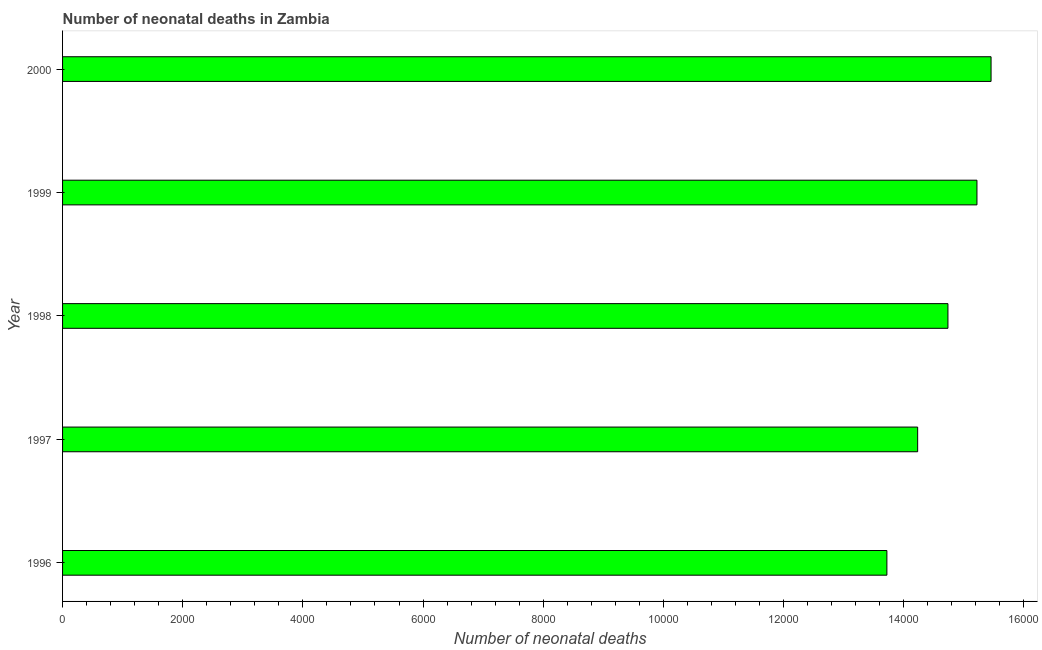Does the graph contain grids?
Your response must be concise. No. What is the title of the graph?
Keep it short and to the point. Number of neonatal deaths in Zambia. What is the label or title of the X-axis?
Your response must be concise. Number of neonatal deaths. What is the number of neonatal deaths in 1999?
Keep it short and to the point. 1.52e+04. Across all years, what is the maximum number of neonatal deaths?
Offer a very short reply. 1.55e+04. Across all years, what is the minimum number of neonatal deaths?
Make the answer very short. 1.37e+04. In which year was the number of neonatal deaths maximum?
Your answer should be very brief. 2000. What is the sum of the number of neonatal deaths?
Your answer should be very brief. 7.34e+04. What is the difference between the number of neonatal deaths in 1997 and 2000?
Ensure brevity in your answer.  -1222. What is the average number of neonatal deaths per year?
Your response must be concise. 1.47e+04. What is the median number of neonatal deaths?
Provide a succinct answer. 1.47e+04. What is the ratio of the number of neonatal deaths in 1996 to that in 1997?
Your response must be concise. 0.96. Is the number of neonatal deaths in 1999 less than that in 2000?
Make the answer very short. Yes. What is the difference between the highest and the second highest number of neonatal deaths?
Offer a terse response. 235. What is the difference between the highest and the lowest number of neonatal deaths?
Keep it short and to the point. 1734. How many years are there in the graph?
Ensure brevity in your answer.  5. Are the values on the major ticks of X-axis written in scientific E-notation?
Provide a short and direct response. No. What is the Number of neonatal deaths in 1996?
Provide a succinct answer. 1.37e+04. What is the Number of neonatal deaths in 1997?
Your answer should be very brief. 1.42e+04. What is the Number of neonatal deaths in 1998?
Your answer should be very brief. 1.47e+04. What is the Number of neonatal deaths in 1999?
Offer a terse response. 1.52e+04. What is the Number of neonatal deaths in 2000?
Provide a short and direct response. 1.55e+04. What is the difference between the Number of neonatal deaths in 1996 and 1997?
Keep it short and to the point. -512. What is the difference between the Number of neonatal deaths in 1996 and 1998?
Your response must be concise. -1016. What is the difference between the Number of neonatal deaths in 1996 and 1999?
Keep it short and to the point. -1499. What is the difference between the Number of neonatal deaths in 1996 and 2000?
Your response must be concise. -1734. What is the difference between the Number of neonatal deaths in 1997 and 1998?
Provide a succinct answer. -504. What is the difference between the Number of neonatal deaths in 1997 and 1999?
Your answer should be compact. -987. What is the difference between the Number of neonatal deaths in 1997 and 2000?
Provide a short and direct response. -1222. What is the difference between the Number of neonatal deaths in 1998 and 1999?
Provide a succinct answer. -483. What is the difference between the Number of neonatal deaths in 1998 and 2000?
Your response must be concise. -718. What is the difference between the Number of neonatal deaths in 1999 and 2000?
Your response must be concise. -235. What is the ratio of the Number of neonatal deaths in 1996 to that in 1997?
Your response must be concise. 0.96. What is the ratio of the Number of neonatal deaths in 1996 to that in 1998?
Make the answer very short. 0.93. What is the ratio of the Number of neonatal deaths in 1996 to that in 1999?
Your answer should be compact. 0.9. What is the ratio of the Number of neonatal deaths in 1996 to that in 2000?
Provide a succinct answer. 0.89. What is the ratio of the Number of neonatal deaths in 1997 to that in 1999?
Offer a terse response. 0.94. What is the ratio of the Number of neonatal deaths in 1997 to that in 2000?
Your response must be concise. 0.92. What is the ratio of the Number of neonatal deaths in 1998 to that in 2000?
Offer a terse response. 0.95. What is the ratio of the Number of neonatal deaths in 1999 to that in 2000?
Your answer should be very brief. 0.98. 